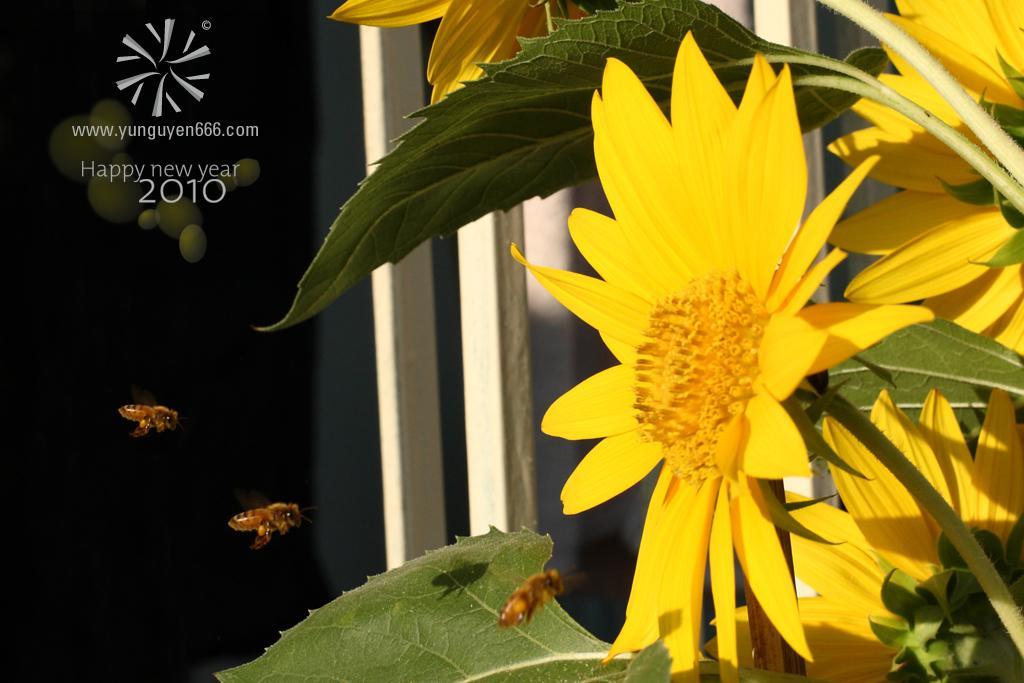How would you summarize this image in a sentence or two? There are flowers and bees in the foreground area of the image, it seems like bamboos and the text in the background. 